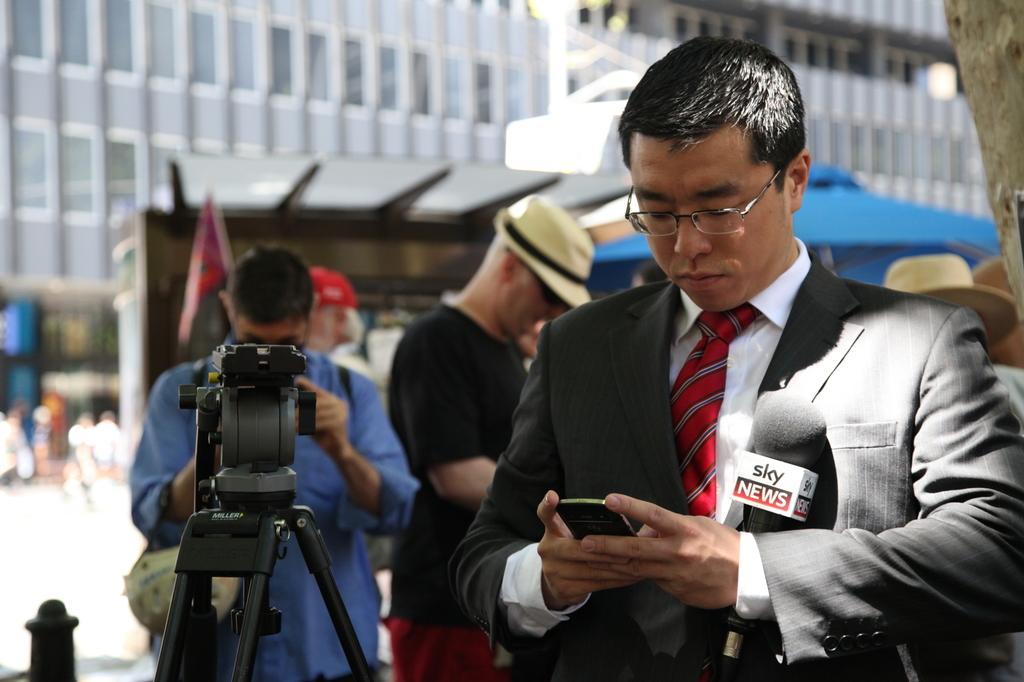Please provide a concise description of this image. In this image we can see persons holding mobile phone. On the left side of the image we can see persons and video camera. In the background we can see flag, persons, tree and road. 